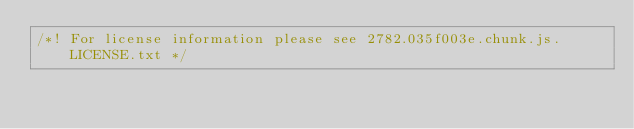Convert code to text. <code><loc_0><loc_0><loc_500><loc_500><_JavaScript_>/*! For license information please see 2782.035f003e.chunk.js.LICENSE.txt */</code> 